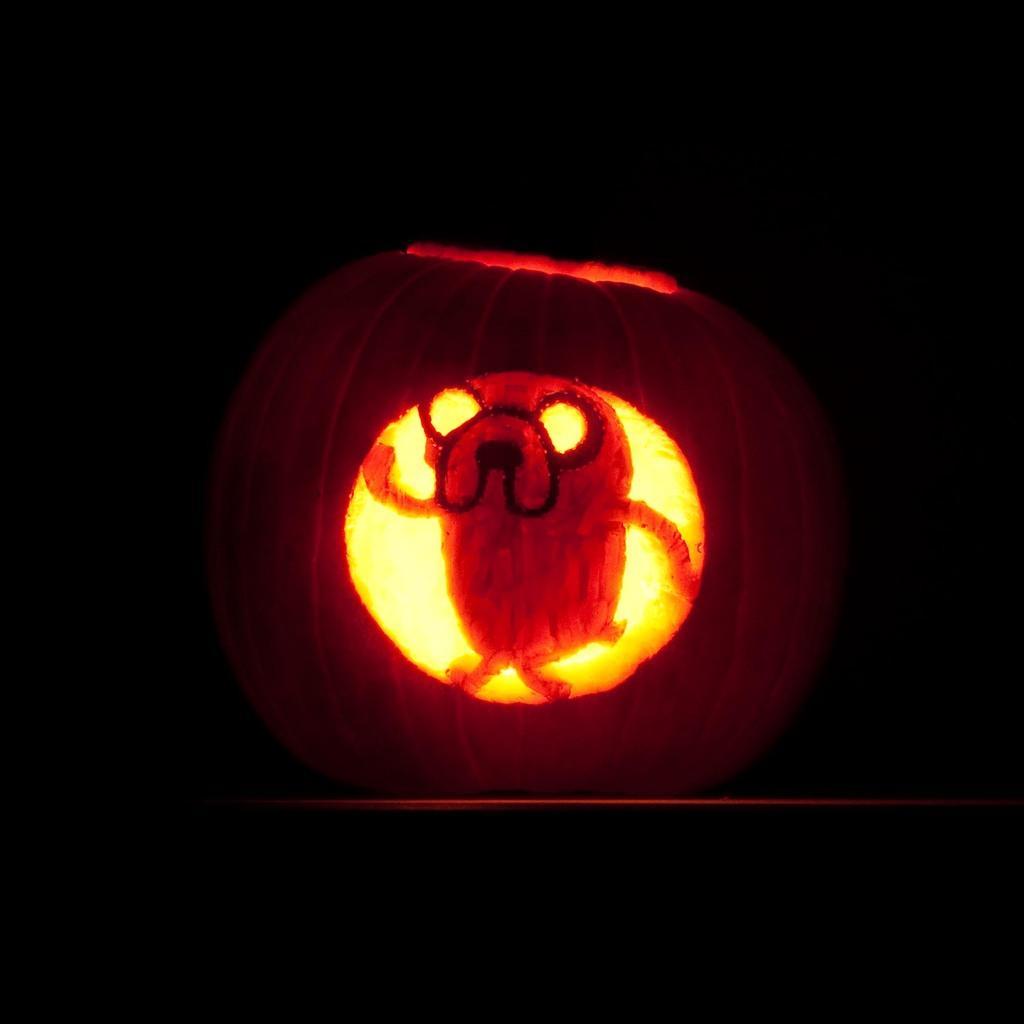Describe this image in one or two sentences. In the image it looks like a halloween pumpkin and the background of the pumpkin is dark. 